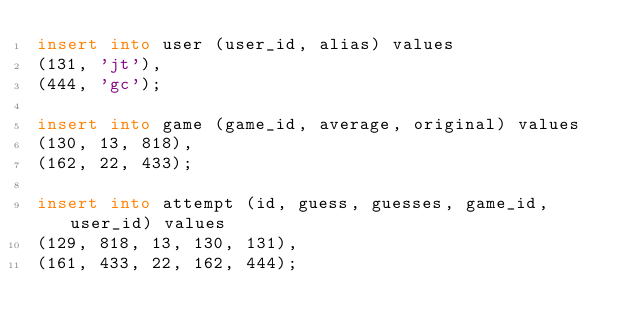<code> <loc_0><loc_0><loc_500><loc_500><_SQL_>insert into user (user_id, alias) values
(131, 'jt'),
(444, 'gc');

insert into game (game_id, average, original) values
(130, 13, 818),
(162, 22, 433);

insert into attempt (id, guess, guesses, game_id, user_id) values
(129, 818, 13, 130, 131),
(161, 433, 22, 162, 444);</code> 